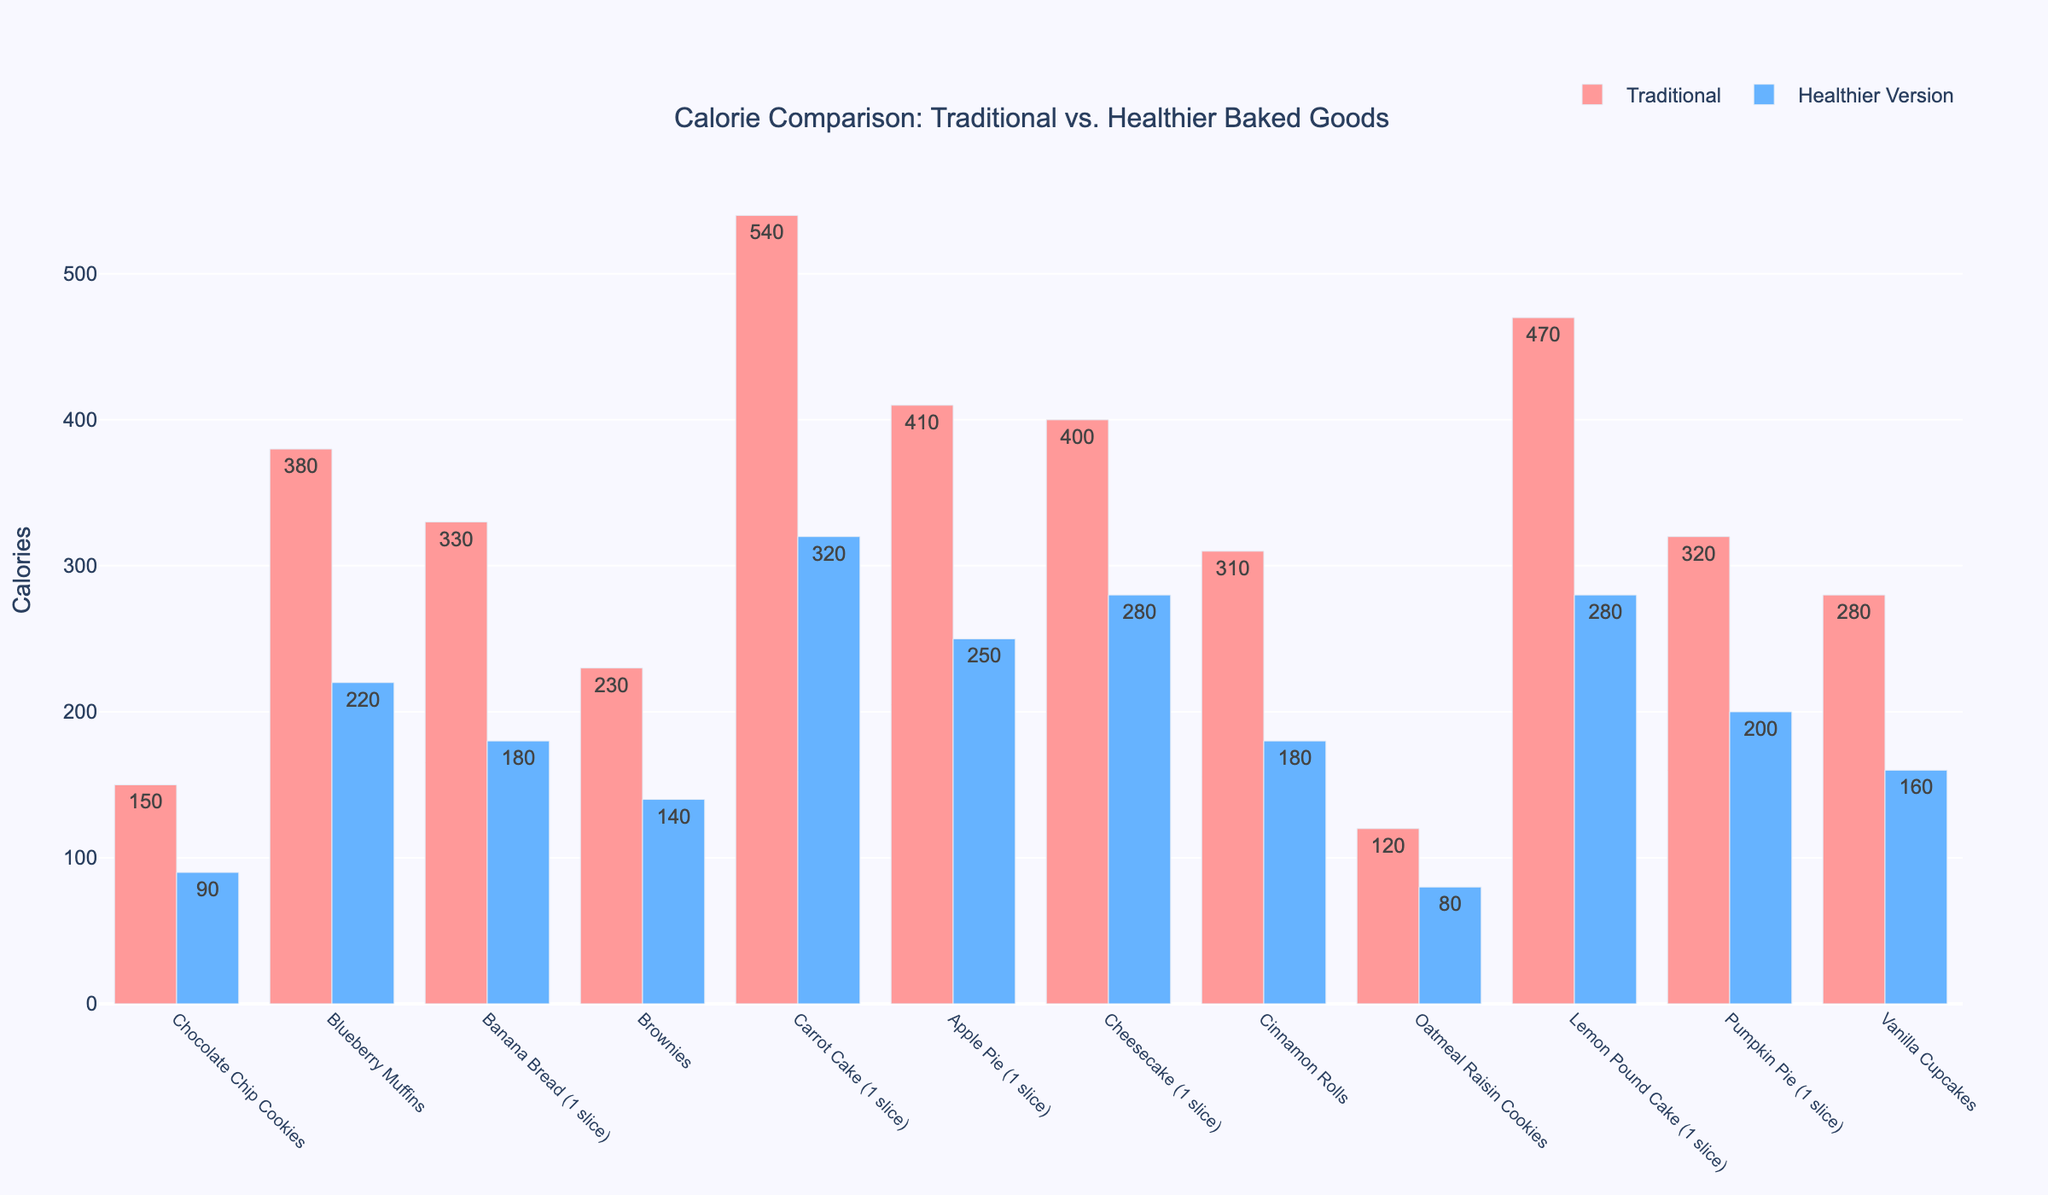Which item has the highest calorie count in its traditional version? To determine the item with the highest calorie count in its traditional version, look for the tallest red bar in the chart. The tallest red bar corresponds to "Carrot Cake," which has 540 calories.
Answer: Carrot Cake How much fewer calories does the healthier version of Chocolate Chip Cookies have compared to the traditional version? Identify the difference in heights of the bars for "Chocolate Chip Cookies." Traditional has 150 calories and the healthier version has 90 calories. Subtract the healthier version's calories from the traditional version's calories (150 - 90).
Answer: 60 Which items have fewer than 200 calories in their healthier versions? Examine the blue bars to identify those shorter than the 200-calorie mark on the y-axis. The items are "Chocolate Chip Cookies" (90), "Oatmeal Raisin Cookies" (80), "Cinnamon Rolls" (180), "Vanilla Cupcakes" (160), "Pumpkin Pie" (200), "Banana Bread" (180).
Answer: Chocolate Chip Cookies, Oatmeal Raisin Cookies, Cinnamon Rolls, Vanilla Cupcakes, Pumpkin Pie, Banana Bread What is the average calorie content of the traditional versions of Chocolate Chip Cookies, Blueberry Muffins, and Banana Bread? Find the values for each item: Chocolate Chip Cookies (150), Blueberry Muffins (380), Banana Bread (330). Sum the values and divide by the number of items (3). (150 + 380 + 330) / 3.
Answer: 286.67 How much greater is the calorie reduction in the healthier version of Cheesecake compared to Oatmeal Raisin Cookies? First, determine the calorie reduction for each item. Traditional Cheesecake (400) - Healthier Cheesecake (280) = 120, Traditional Oatmeal Raisin Cookies (120) - Healthier Oatmeal Raisin Cookies (80) = 40. Finally, subtract the reduction for Oatmeal Raisin Cookies from Cheesecake (120 - 40).
Answer: 80 